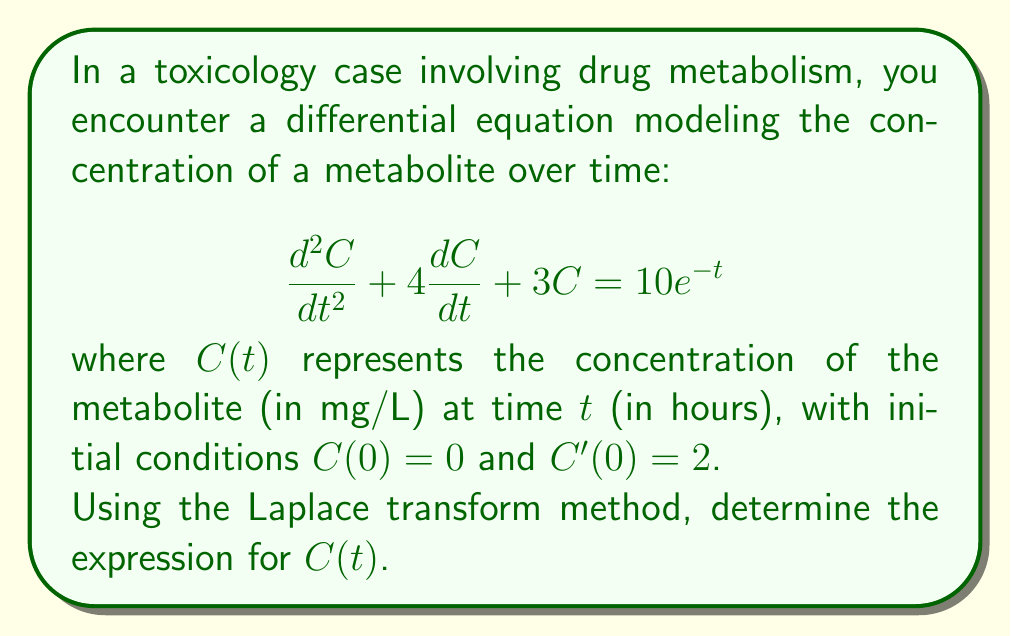Teach me how to tackle this problem. Let's solve this step-by-step using the Laplace transform method:

1) Take the Laplace transform of both sides of the equation:
   $$\mathcal{L}\{C''(t) + 4C'(t) + 3C(t)\} = \mathcal{L}\{10e^{-t}\}$$

2) Using Laplace transform properties:
   $$[s^2C(s) - sC(0) - C'(0)] + 4[sC(s) - C(0)] + 3C(s) = \frac{10}{s+1}$$

3) Substitute the initial conditions $C(0) = 0$ and $C'(0) = 2$:
   $$s^2C(s) - 2 + 4sC(s) + 3C(s) = \frac{10}{s+1}$$

4) Combine like terms:
   $$(s^2 + 4s + 3)C(s) = \frac{10}{s+1} + 2$$

5) Solve for $C(s)$:
   $$C(s) = \frac{10}{(s+1)(s^2 + 4s + 3)} + \frac{2}{s^2 + 4s + 3}$$

6) Use partial fraction decomposition:
   $$C(s) = \frac{A}{s+1} + \frac{B}{s+1} + \frac{Cs+D}{s^2 + 4s + 3}$$

7) Solve for $A$, $B$, $C$, and $D$:
   $$C(s) = \frac{5}{2(s+1)} - \frac{5}{2(s+3)} + \frac{1}{2(s+1)} - \frac{1}{2(s+3)}$$

8) Simplify:
   $$C(s) = \frac{3}{s+1} - \frac{3}{s+3}$$

9) Take the inverse Laplace transform:
   $$C(t) = 3e^{-t} - 3e^{-3t}$$

Thus, we have found the expression for $C(t)$.
Answer: $C(t) = 3e^{-t} - 3e^{-3t}$ 